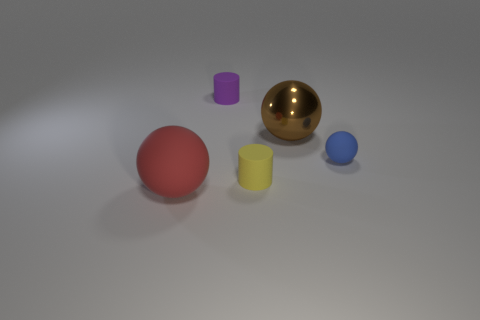The ball left of the big object that is right of the cylinder behind the big brown metallic sphere is made of what material?
Provide a succinct answer. Rubber. Are the tiny blue thing that is behind the large matte thing and the big brown sphere made of the same material?
Make the answer very short. No. What number of brown metallic balls are the same size as the yellow matte cylinder?
Provide a succinct answer. 0. Are there more big red matte things that are in front of the red rubber sphere than tiny matte cylinders that are to the right of the big brown metallic object?
Give a very brief answer. No. Are there any brown rubber objects that have the same shape as the purple object?
Give a very brief answer. No. What is the size of the sphere that is on the left side of the big ball that is behind the yellow cylinder?
Keep it short and to the point. Large. There is a large thing behind the matte thing on the left side of the rubber cylinder that is behind the yellow rubber object; what is its shape?
Your response must be concise. Sphere. What size is the purple thing that is the same material as the small ball?
Offer a very short reply. Small. Are there more red rubber balls than balls?
Make the answer very short. No. There is another sphere that is the same size as the brown metallic ball; what is its material?
Provide a succinct answer. Rubber. 